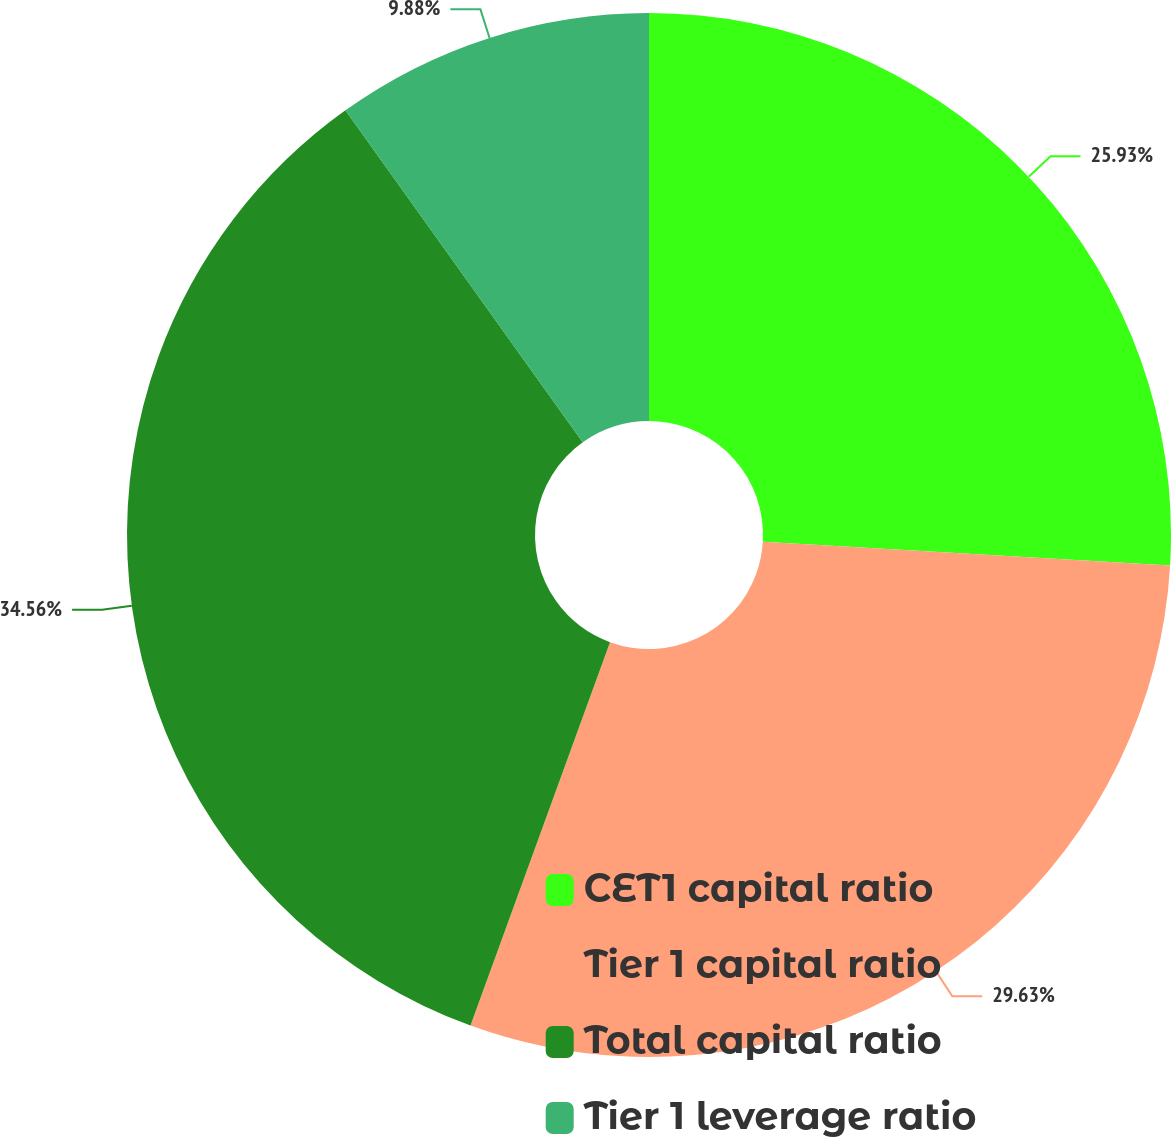Convert chart to OTSL. <chart><loc_0><loc_0><loc_500><loc_500><pie_chart><fcel>CET1 capital ratio<fcel>Tier 1 capital ratio<fcel>Total capital ratio<fcel>Tier 1 leverage ratio<nl><fcel>25.93%<fcel>29.63%<fcel>34.57%<fcel>9.88%<nl></chart> 